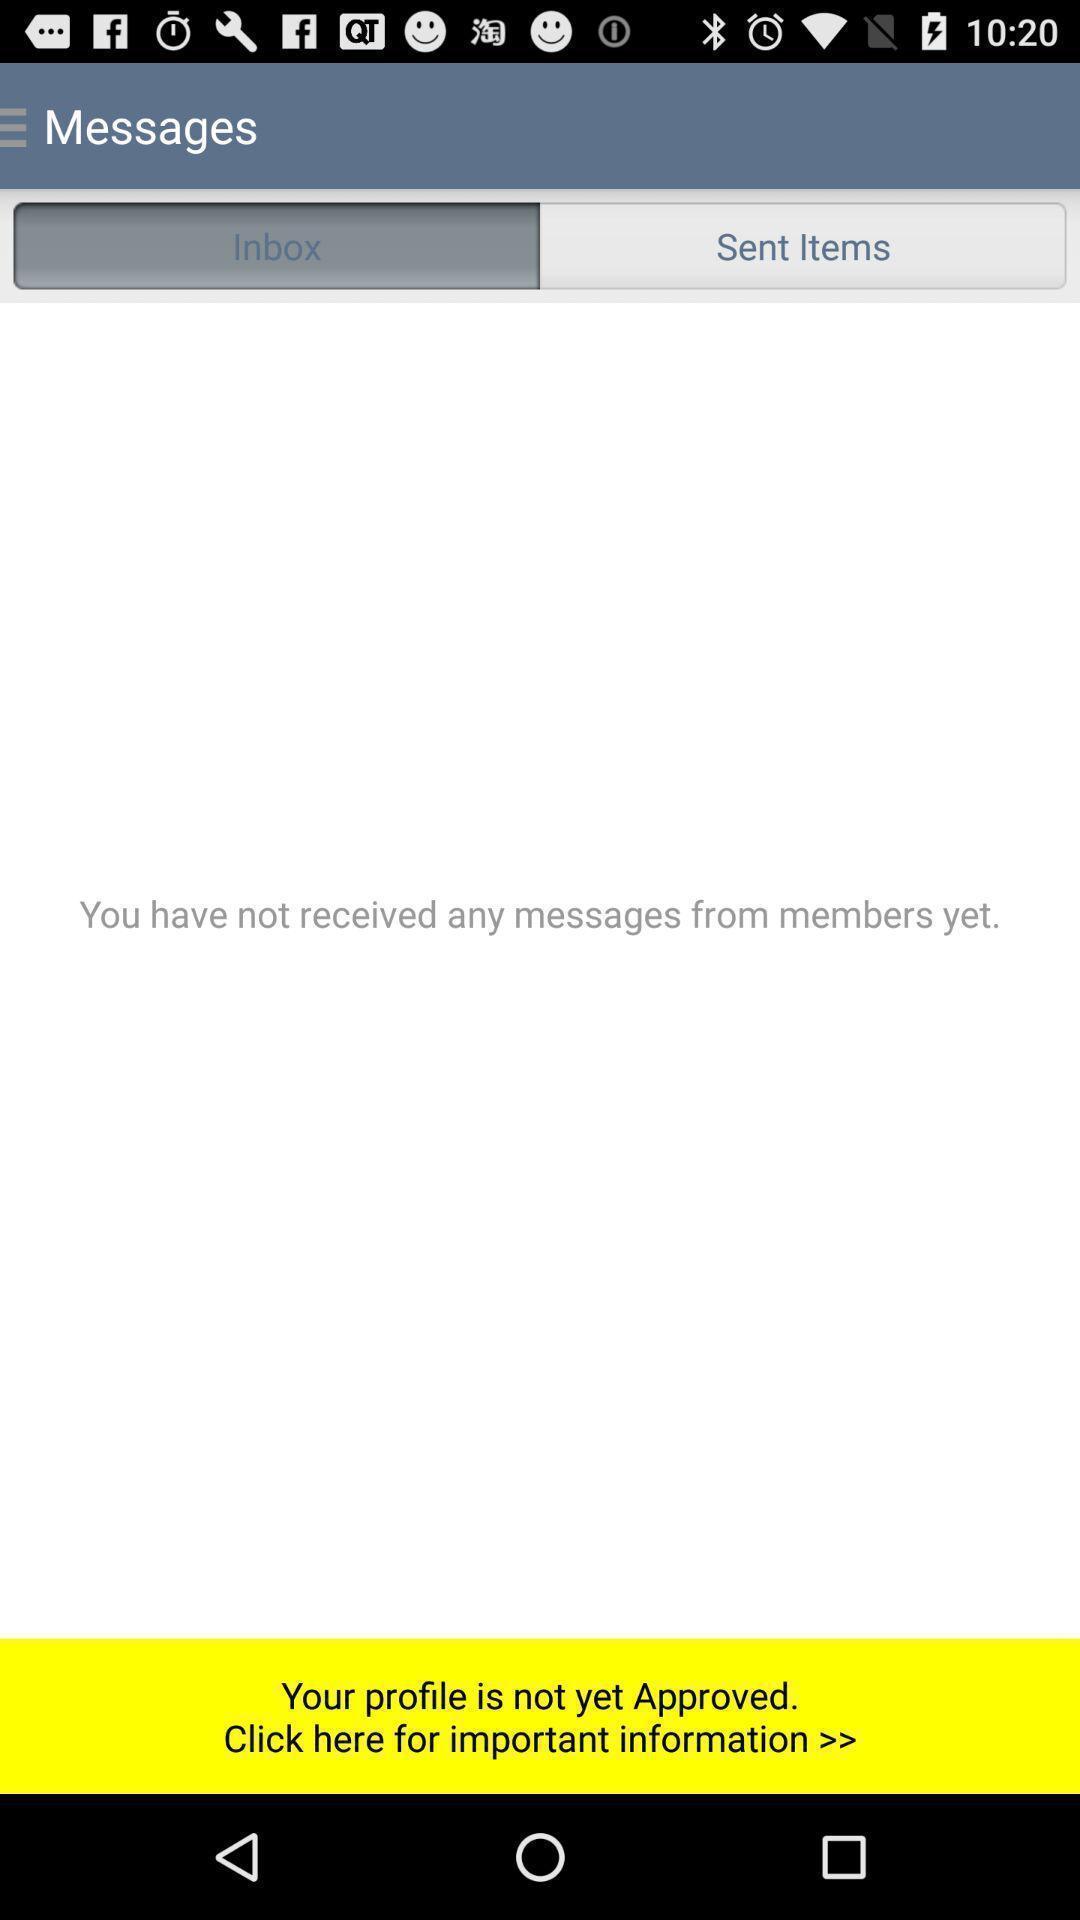Explain the elements present in this screenshot. Screen displaying contents in message page. 